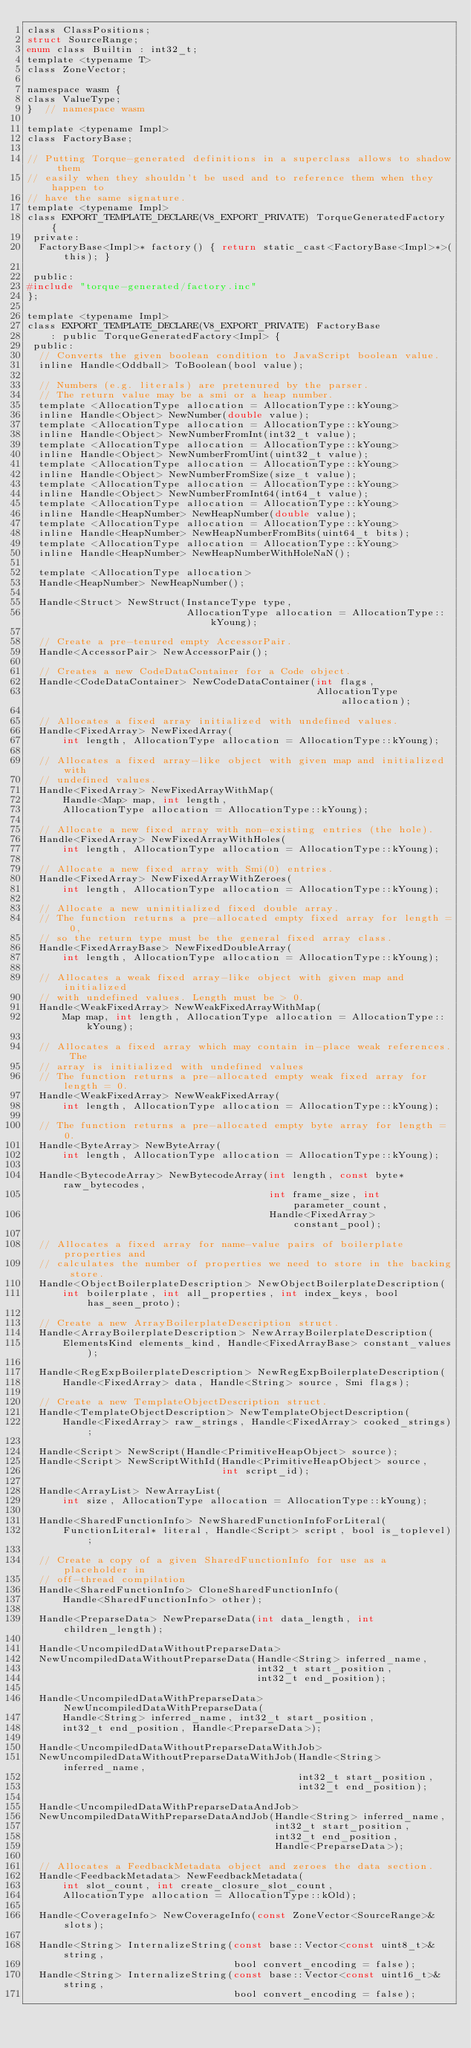<code> <loc_0><loc_0><loc_500><loc_500><_C_>class ClassPositions;
struct SourceRange;
enum class Builtin : int32_t;
template <typename T>
class ZoneVector;

namespace wasm {
class ValueType;
}  // namespace wasm

template <typename Impl>
class FactoryBase;

// Putting Torque-generated definitions in a superclass allows to shadow them
// easily when they shouldn't be used and to reference them when they happen to
// have the same signature.
template <typename Impl>
class EXPORT_TEMPLATE_DECLARE(V8_EXPORT_PRIVATE) TorqueGeneratedFactory {
 private:
  FactoryBase<Impl>* factory() { return static_cast<FactoryBase<Impl>*>(this); }

 public:
#include "torque-generated/factory.inc"
};

template <typename Impl>
class EXPORT_TEMPLATE_DECLARE(V8_EXPORT_PRIVATE) FactoryBase
    : public TorqueGeneratedFactory<Impl> {
 public:
  // Converts the given boolean condition to JavaScript boolean value.
  inline Handle<Oddball> ToBoolean(bool value);

  // Numbers (e.g. literals) are pretenured by the parser.
  // The return value may be a smi or a heap number.
  template <AllocationType allocation = AllocationType::kYoung>
  inline Handle<Object> NewNumber(double value);
  template <AllocationType allocation = AllocationType::kYoung>
  inline Handle<Object> NewNumberFromInt(int32_t value);
  template <AllocationType allocation = AllocationType::kYoung>
  inline Handle<Object> NewNumberFromUint(uint32_t value);
  template <AllocationType allocation = AllocationType::kYoung>
  inline Handle<Object> NewNumberFromSize(size_t value);
  template <AllocationType allocation = AllocationType::kYoung>
  inline Handle<Object> NewNumberFromInt64(int64_t value);
  template <AllocationType allocation = AllocationType::kYoung>
  inline Handle<HeapNumber> NewHeapNumber(double value);
  template <AllocationType allocation = AllocationType::kYoung>
  inline Handle<HeapNumber> NewHeapNumberFromBits(uint64_t bits);
  template <AllocationType allocation = AllocationType::kYoung>
  inline Handle<HeapNumber> NewHeapNumberWithHoleNaN();

  template <AllocationType allocation>
  Handle<HeapNumber> NewHeapNumber();

  Handle<Struct> NewStruct(InstanceType type,
                           AllocationType allocation = AllocationType::kYoung);

  // Create a pre-tenured empty AccessorPair.
  Handle<AccessorPair> NewAccessorPair();

  // Creates a new CodeDataContainer for a Code object.
  Handle<CodeDataContainer> NewCodeDataContainer(int flags,
                                                 AllocationType allocation);

  // Allocates a fixed array initialized with undefined values.
  Handle<FixedArray> NewFixedArray(
      int length, AllocationType allocation = AllocationType::kYoung);

  // Allocates a fixed array-like object with given map and initialized with
  // undefined values.
  Handle<FixedArray> NewFixedArrayWithMap(
      Handle<Map> map, int length,
      AllocationType allocation = AllocationType::kYoung);

  // Allocate a new fixed array with non-existing entries (the hole).
  Handle<FixedArray> NewFixedArrayWithHoles(
      int length, AllocationType allocation = AllocationType::kYoung);

  // Allocate a new fixed array with Smi(0) entries.
  Handle<FixedArray> NewFixedArrayWithZeroes(
      int length, AllocationType allocation = AllocationType::kYoung);

  // Allocate a new uninitialized fixed double array.
  // The function returns a pre-allocated empty fixed array for length = 0,
  // so the return type must be the general fixed array class.
  Handle<FixedArrayBase> NewFixedDoubleArray(
      int length, AllocationType allocation = AllocationType::kYoung);

  // Allocates a weak fixed array-like object with given map and initialized
  // with undefined values. Length must be > 0.
  Handle<WeakFixedArray> NewWeakFixedArrayWithMap(
      Map map, int length, AllocationType allocation = AllocationType::kYoung);

  // Allocates a fixed array which may contain in-place weak references. The
  // array is initialized with undefined values
  // The function returns a pre-allocated empty weak fixed array for length = 0.
  Handle<WeakFixedArray> NewWeakFixedArray(
      int length, AllocationType allocation = AllocationType::kYoung);

  // The function returns a pre-allocated empty byte array for length = 0.
  Handle<ByteArray> NewByteArray(
      int length, AllocationType allocation = AllocationType::kYoung);

  Handle<BytecodeArray> NewBytecodeArray(int length, const byte* raw_bytecodes,
                                         int frame_size, int parameter_count,
                                         Handle<FixedArray> constant_pool);

  // Allocates a fixed array for name-value pairs of boilerplate properties and
  // calculates the number of properties we need to store in the backing store.
  Handle<ObjectBoilerplateDescription> NewObjectBoilerplateDescription(
      int boilerplate, int all_properties, int index_keys, bool has_seen_proto);

  // Create a new ArrayBoilerplateDescription struct.
  Handle<ArrayBoilerplateDescription> NewArrayBoilerplateDescription(
      ElementsKind elements_kind, Handle<FixedArrayBase> constant_values);

  Handle<RegExpBoilerplateDescription> NewRegExpBoilerplateDescription(
      Handle<FixedArray> data, Handle<String> source, Smi flags);

  // Create a new TemplateObjectDescription struct.
  Handle<TemplateObjectDescription> NewTemplateObjectDescription(
      Handle<FixedArray> raw_strings, Handle<FixedArray> cooked_strings);

  Handle<Script> NewScript(Handle<PrimitiveHeapObject> source);
  Handle<Script> NewScriptWithId(Handle<PrimitiveHeapObject> source,
                                 int script_id);

  Handle<ArrayList> NewArrayList(
      int size, AllocationType allocation = AllocationType::kYoung);

  Handle<SharedFunctionInfo> NewSharedFunctionInfoForLiteral(
      FunctionLiteral* literal, Handle<Script> script, bool is_toplevel);

  // Create a copy of a given SharedFunctionInfo for use as a placeholder in
  // off-thread compilation
  Handle<SharedFunctionInfo> CloneSharedFunctionInfo(
      Handle<SharedFunctionInfo> other);

  Handle<PreparseData> NewPreparseData(int data_length, int children_length);

  Handle<UncompiledDataWithoutPreparseData>
  NewUncompiledDataWithoutPreparseData(Handle<String> inferred_name,
                                       int32_t start_position,
                                       int32_t end_position);

  Handle<UncompiledDataWithPreparseData> NewUncompiledDataWithPreparseData(
      Handle<String> inferred_name, int32_t start_position,
      int32_t end_position, Handle<PreparseData>);

  Handle<UncompiledDataWithoutPreparseDataWithJob>
  NewUncompiledDataWithoutPreparseDataWithJob(Handle<String> inferred_name,
                                              int32_t start_position,
                                              int32_t end_position);

  Handle<UncompiledDataWithPreparseDataAndJob>
  NewUncompiledDataWithPreparseDataAndJob(Handle<String> inferred_name,
                                          int32_t start_position,
                                          int32_t end_position,
                                          Handle<PreparseData>);

  // Allocates a FeedbackMetadata object and zeroes the data section.
  Handle<FeedbackMetadata> NewFeedbackMetadata(
      int slot_count, int create_closure_slot_count,
      AllocationType allocation = AllocationType::kOld);

  Handle<CoverageInfo> NewCoverageInfo(const ZoneVector<SourceRange>& slots);

  Handle<String> InternalizeString(const base::Vector<const uint8_t>& string,
                                   bool convert_encoding = false);
  Handle<String> InternalizeString(const base::Vector<const uint16_t>& string,
                                   bool convert_encoding = false);
</code> 